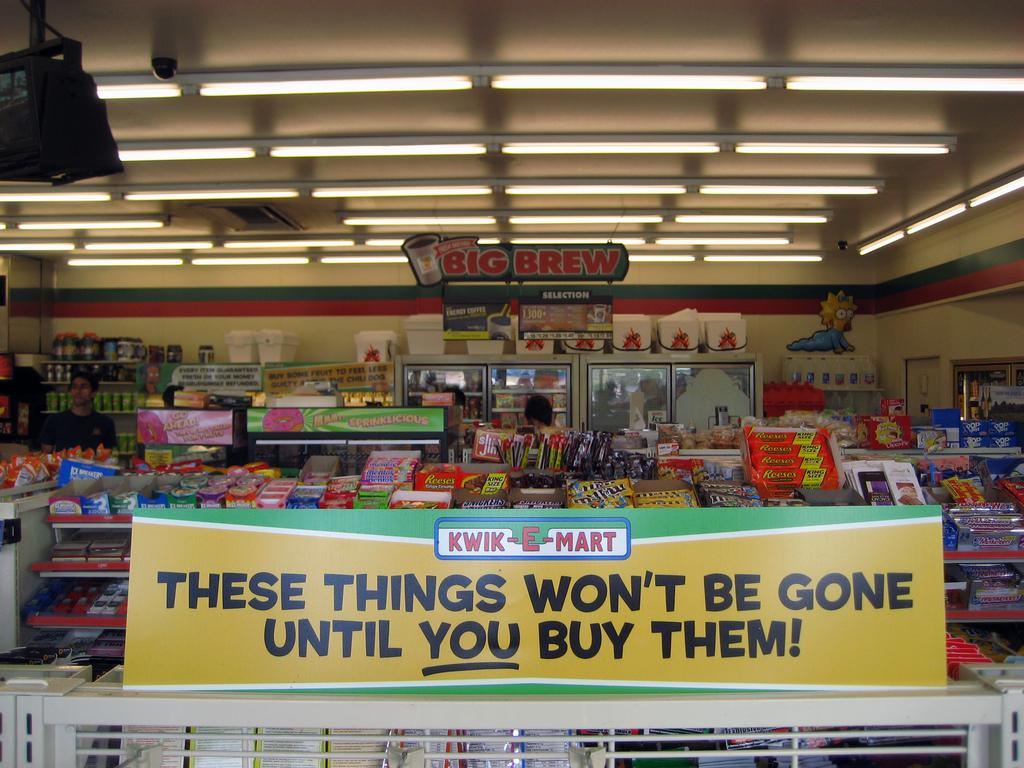<image>
Offer a succinct explanation of the picture presented. A kwik mart sign that says the things wont be gone till you buy them. 